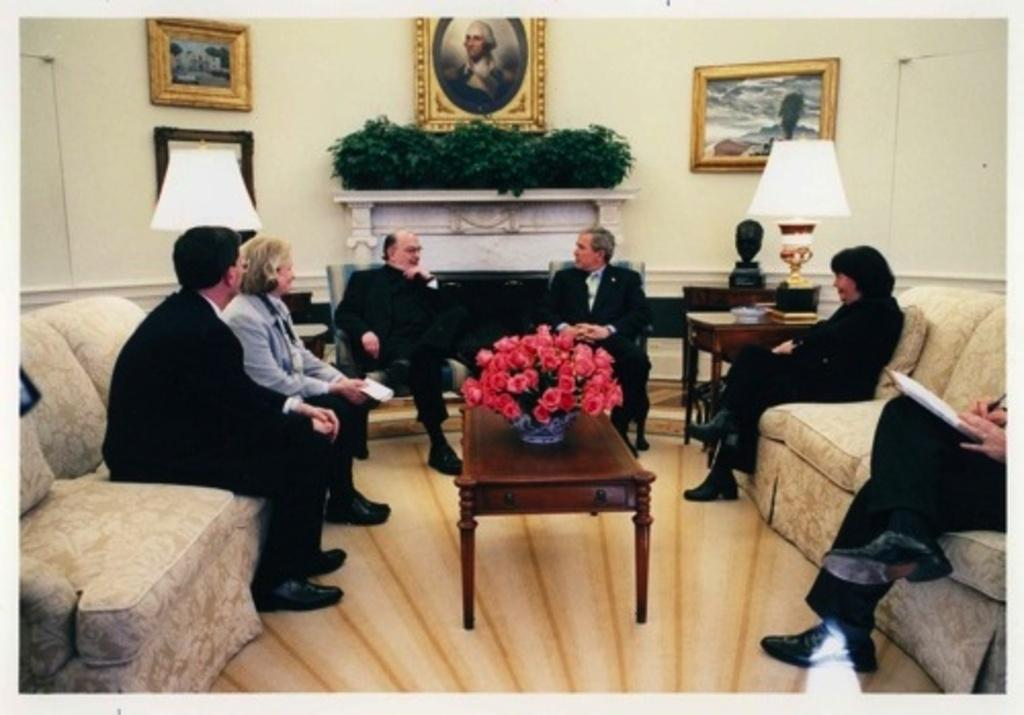What are the people in the image doing? There is a group of people sitting on a couch in the image. What is between the people sitting on the couch? There is a table between the people. What is on the table? There is a flower vase on the table. What can be seen in the background of the image? There are plants, a lamp, frames, and a fireplace in the background. What type of lock is used to secure the passenger's degree in the image? There is no lock, passenger, or degree present in the image. 